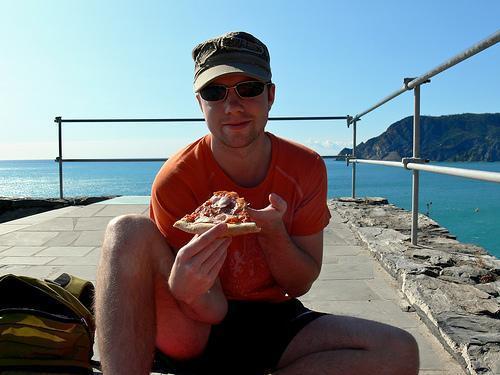How many people are there?
Give a very brief answer. 1. 